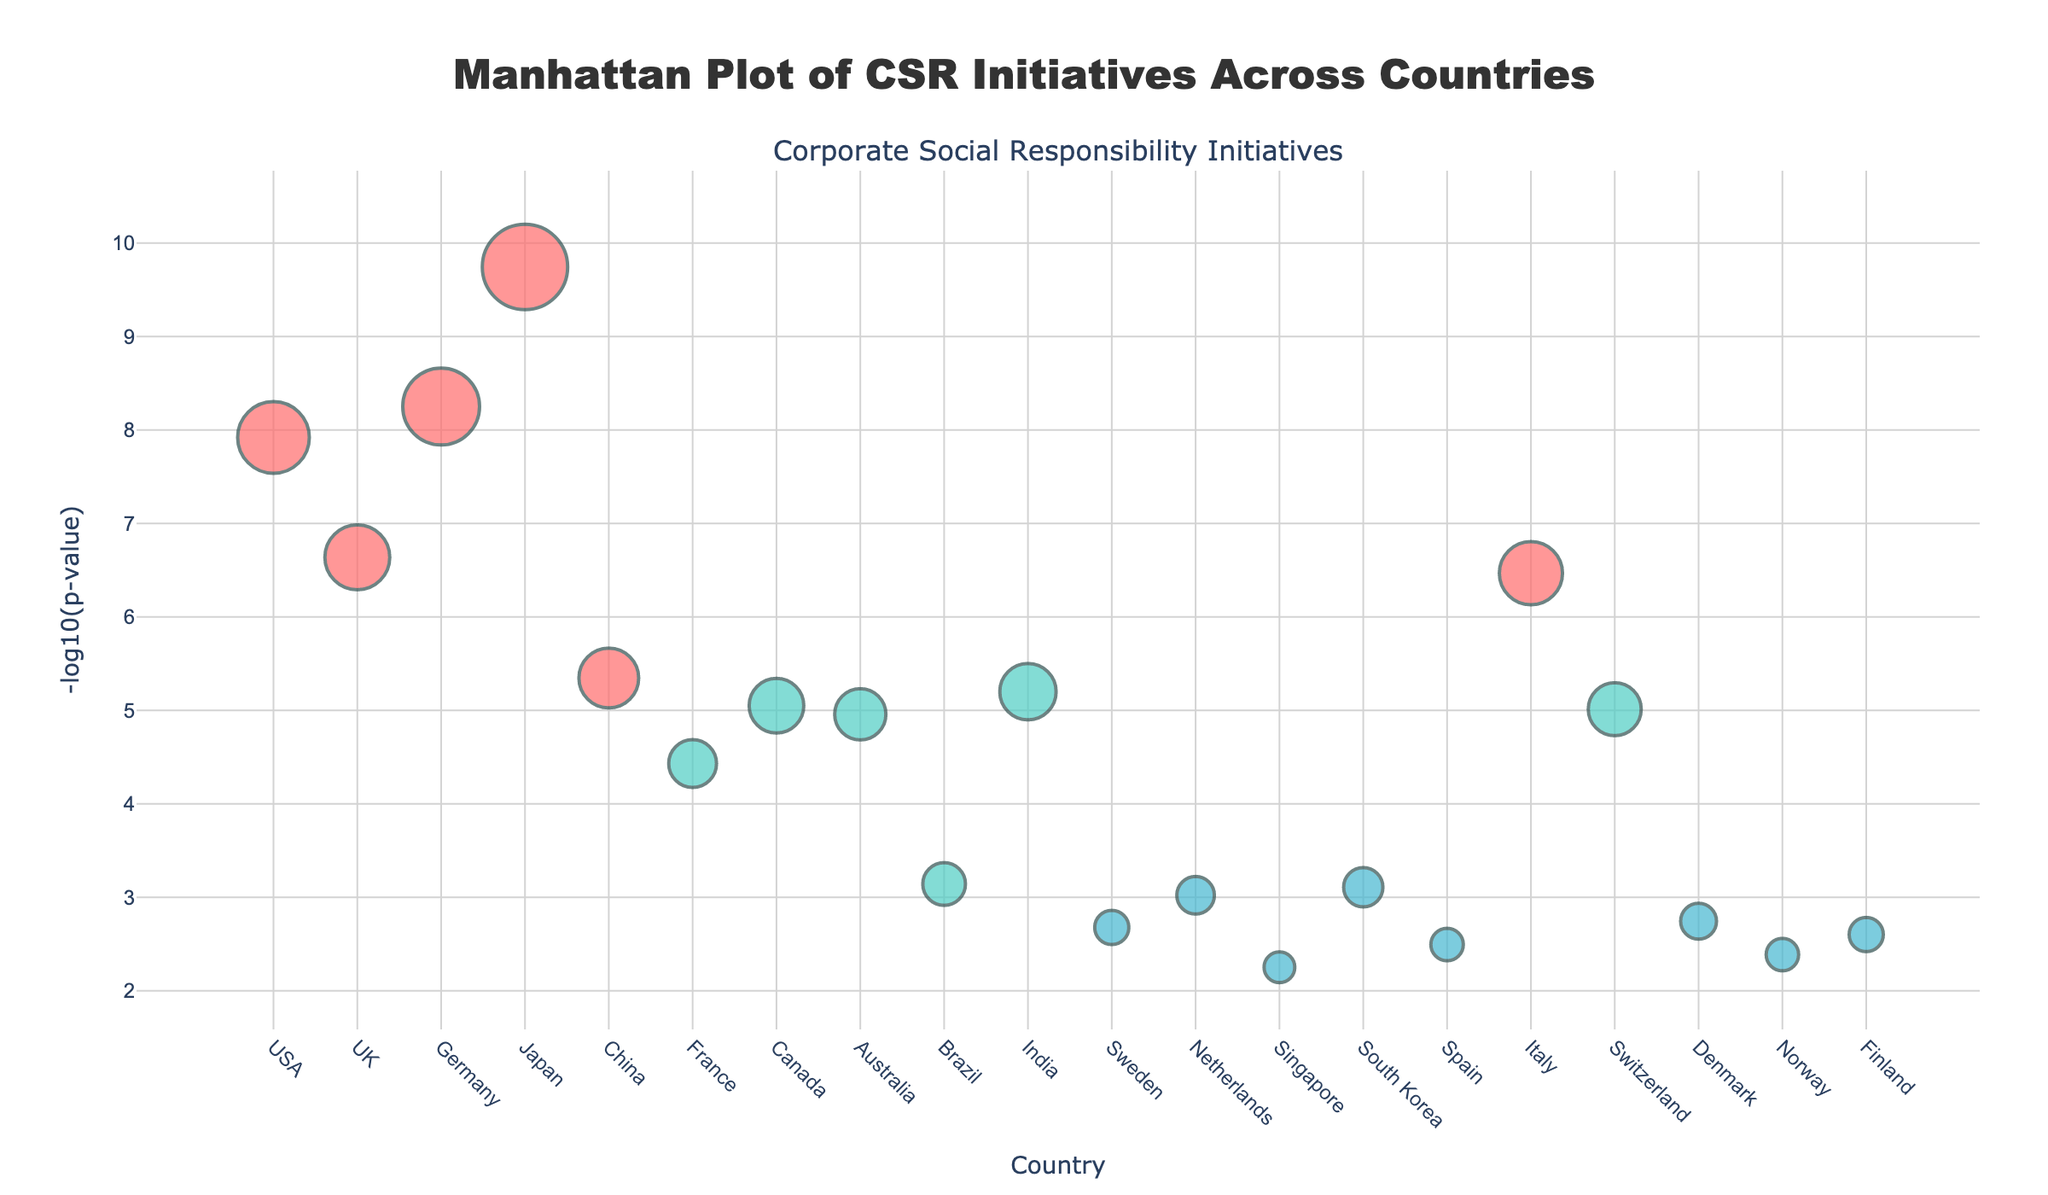What's the title of the plot? The title of the plot is typically found at the top of the figure and provides a summary of what the plot represents. In this case, it is "Manhattan Plot of CSR Initiatives Across Countries".
Answer: "Manhattan Plot of CSR Initiatives Across Countries" Which country has the highest frequency of CSR initiatives for large companies? From the plot, each marker represents a country, with the CSR Initiatives Frequency encoded in the size of the markers. The country with the largest marker among large companies is Japan.
Answer: Japan What is the y-axis representing in the figure? The y-axis typically represents the dependent variable or measure of interest, which in this case is labelled as '-log10(p-value)'. This value indicates the logarithmic transformation of the p-values associated with CSR initiatives frequencies.
Answer: -log10(p-value) How many countries are depicted for medium-sized companies? From the color legend, medium-sized companies are represented by the color '#4ECDC4'. By counting the markers of this color, we can see that there are six countries depicted for medium-sized companies.
Answer: Six Which country among small companies has the lowest logged p-value? The lowest logged p-value for small companies can be identified by finding the highest y-value among markers that are the color representing small companies (#45B7D1). The country with this highest y-value (lowest p-value) is South Korea.
Answer: South Korea What is the logged p-value for Australia, and what is its company size? Locate the marker representing Australia in the plot, and follow the y-axis to determine the value. Australia is a medium-sized company, and its marker intersects at around -log10(1.1e-5).
Answer: -log10(1.1e-5), Medium-sized Rank the countries with large companies in descending order of CSR initiative frequency. From the plot, we look at the sizes of the markers categorized as large companies. In descending order: Japan (50), Germany (45), USA (42), Italy (37), UK (38), China (35).
Answer: Japan, Germany, USA, UK, Italy, China Which two similarly-sized countries have the closest frequencies of CSR initiatives? By comparing the frequencies visually, Brazil and Australia both medium-sized companies have very close frequencies with Brazil at (25) and Australia at (30).
Answer: Brazil and Australia Find the average logged p-value for small companies. Identify logged p-values for small companies: [2.1, 9.5, 5.6, 7.8, 3.2, 2.5]. These correspond to the values on the y-axis, then average these values: (2.1 + 9.5 + 5.6 + 7.8 + 3.2 + 2.5)/6 ≈ 5.12.
Answer: 5.12 